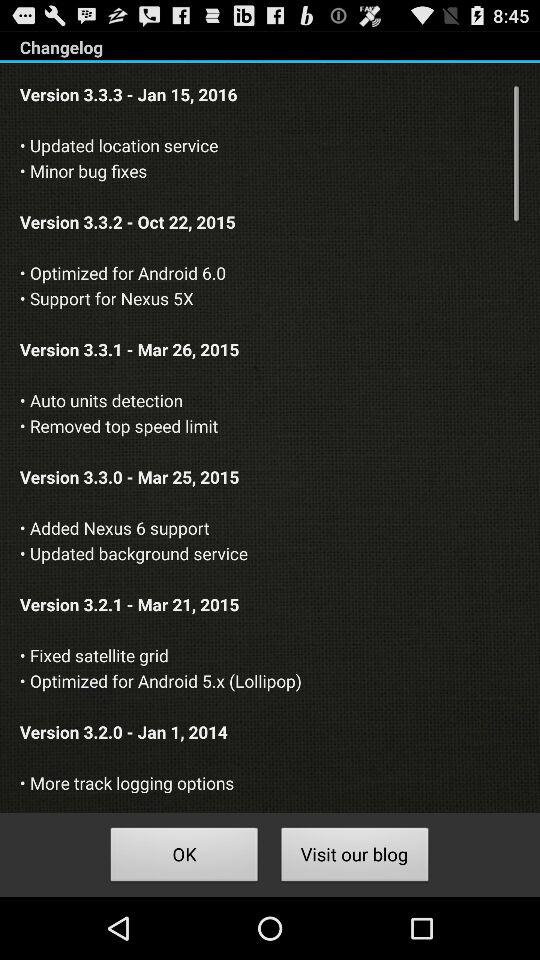What are the updates in version 3.3.0? The updates are "Added Nexus 6 support" and "Updated background service". 